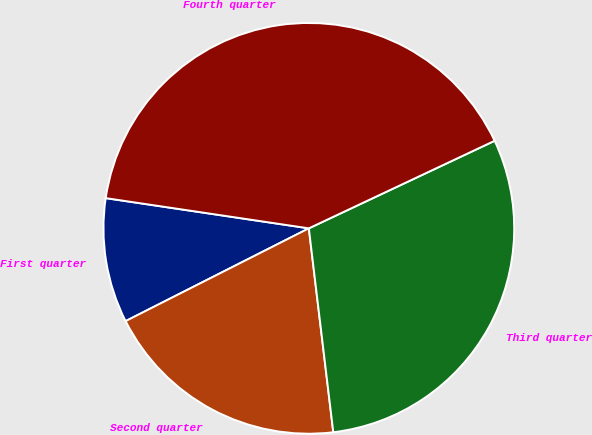Convert chart. <chart><loc_0><loc_0><loc_500><loc_500><pie_chart><fcel>First quarter<fcel>Second quarter<fcel>Third quarter<fcel>Fourth quarter<nl><fcel>9.81%<fcel>19.44%<fcel>30.11%<fcel>40.64%<nl></chart> 